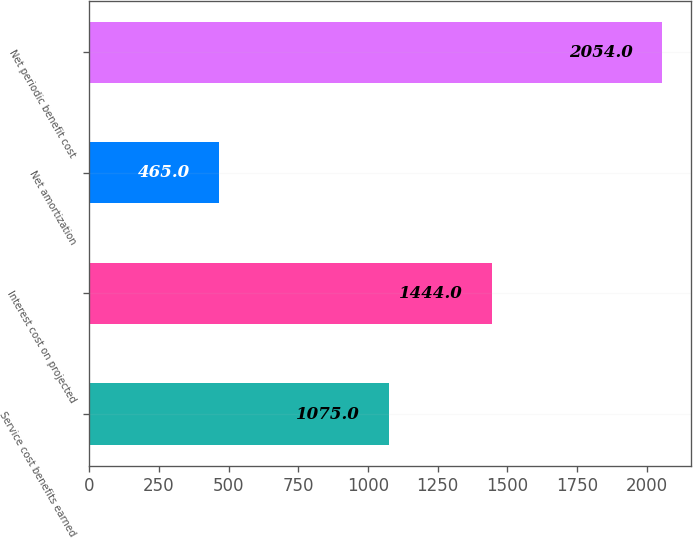Convert chart. <chart><loc_0><loc_0><loc_500><loc_500><bar_chart><fcel>Service cost benefits earned<fcel>Interest cost on projected<fcel>Net amortization<fcel>Net periodic benefit cost<nl><fcel>1075<fcel>1444<fcel>465<fcel>2054<nl></chart> 